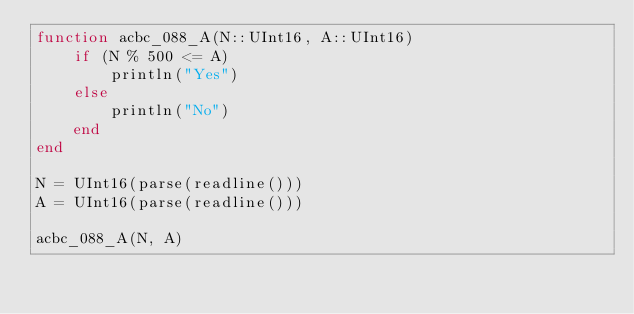<code> <loc_0><loc_0><loc_500><loc_500><_Julia_>function acbc_088_A(N::UInt16, A::UInt16)
    if (N % 500 <= A)
        println("Yes")
    else
        println("No")
    end
end
 
N = UInt16(parse(readline()))
A = UInt16(parse(readline()))
 
acbc_088_A(N, A)</code> 